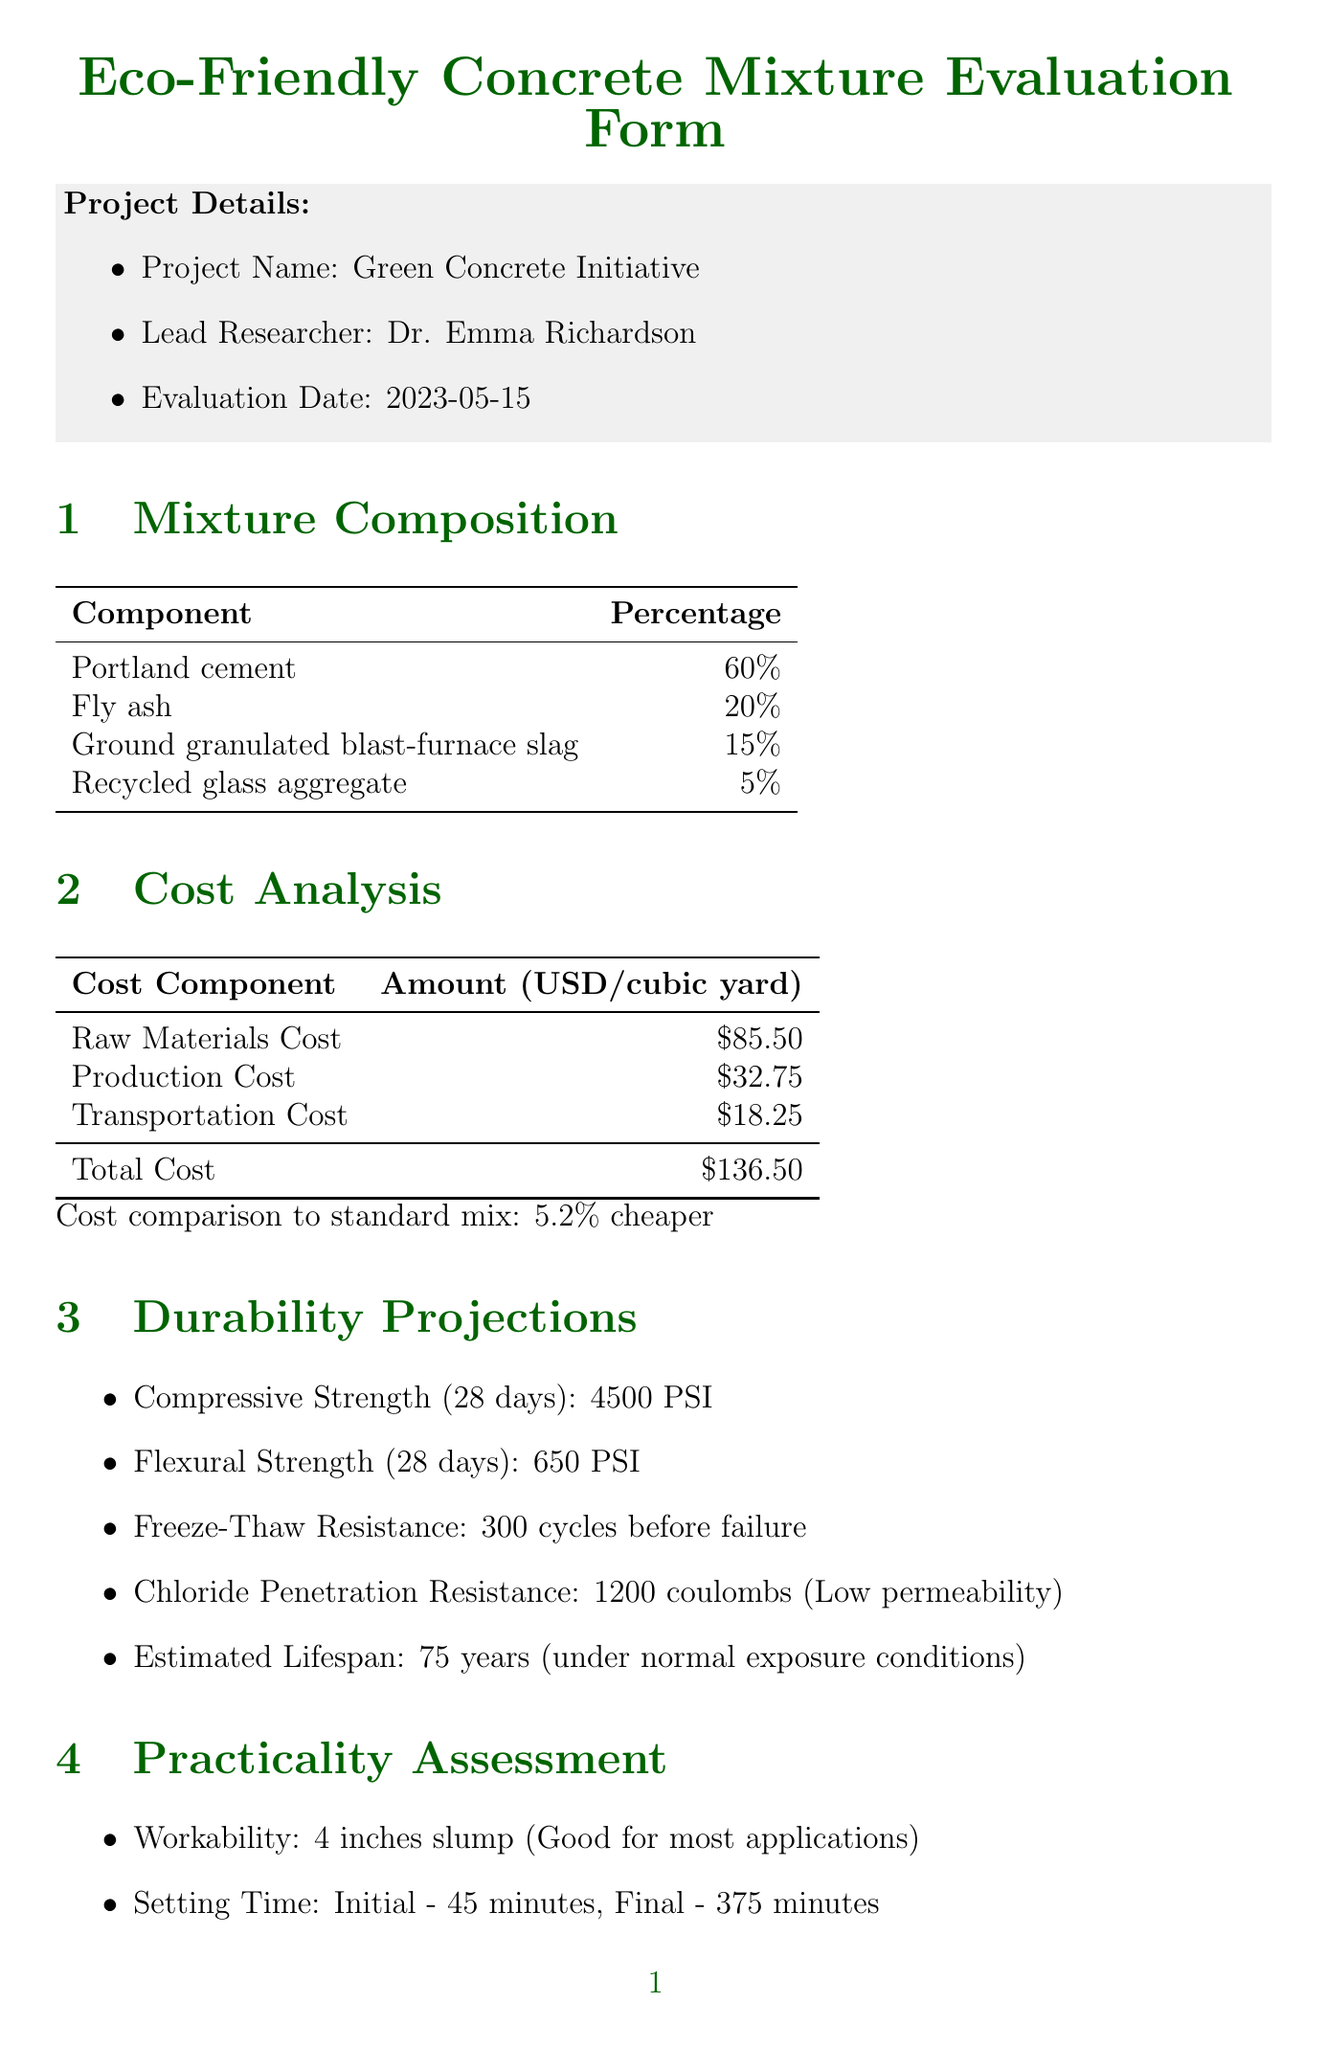what is the project name? The project name is listed in the project details section.
Answer: Green Concrete Initiative who is the lead researcher? The lead researcher is mentioned in the project details.
Answer: Dr. Emma Richardson what is the total cost per cubic yard? The total cost is provided under the cost analysis section.
Answer: 136.50 USD how many years is the estimated lifespan? The estimated lifespan is specified in the durability projections section.
Answer: 75 years what is the percentage reduction in carbon footprint? The reduction in carbon footprint is found in the environmental impact section.
Answer: 18 what is the pumpability rating? The pumpability rating is included in the practicality assessment section.
Answer: 8 how many cycles can the concrete withstand in freeze-thaw resistance? The freeze-thaw resistance is discussed in the durability projections section.
Answer: 300 what are the potential challenges to address? The challenges are listed under contractor recommendations.
Answer: Worker training on handling and placing how does the cost compare to standard mix? The cost comparison is mentioned in the cost analysis section.
Answer: 5.2% cheaper 